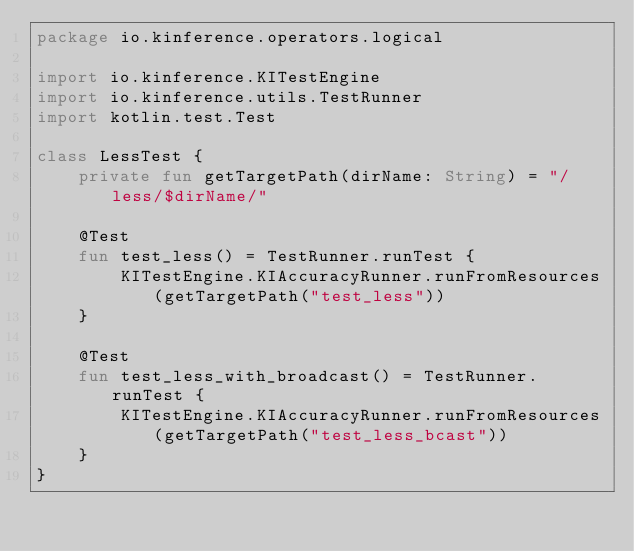<code> <loc_0><loc_0><loc_500><loc_500><_Kotlin_>package io.kinference.operators.logical

import io.kinference.KITestEngine
import io.kinference.utils.TestRunner
import kotlin.test.Test

class LessTest {
    private fun getTargetPath(dirName: String) = "/less/$dirName/"

    @Test
    fun test_less() = TestRunner.runTest {
        KITestEngine.KIAccuracyRunner.runFromResources(getTargetPath("test_less"))
    }

    @Test
    fun test_less_with_broadcast() = TestRunner.runTest {
        KITestEngine.KIAccuracyRunner.runFromResources(getTargetPath("test_less_bcast"))
    }
}
</code> 